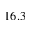Convert formula to latex. <formula><loc_0><loc_0><loc_500><loc_500>1 6 . 3</formula> 